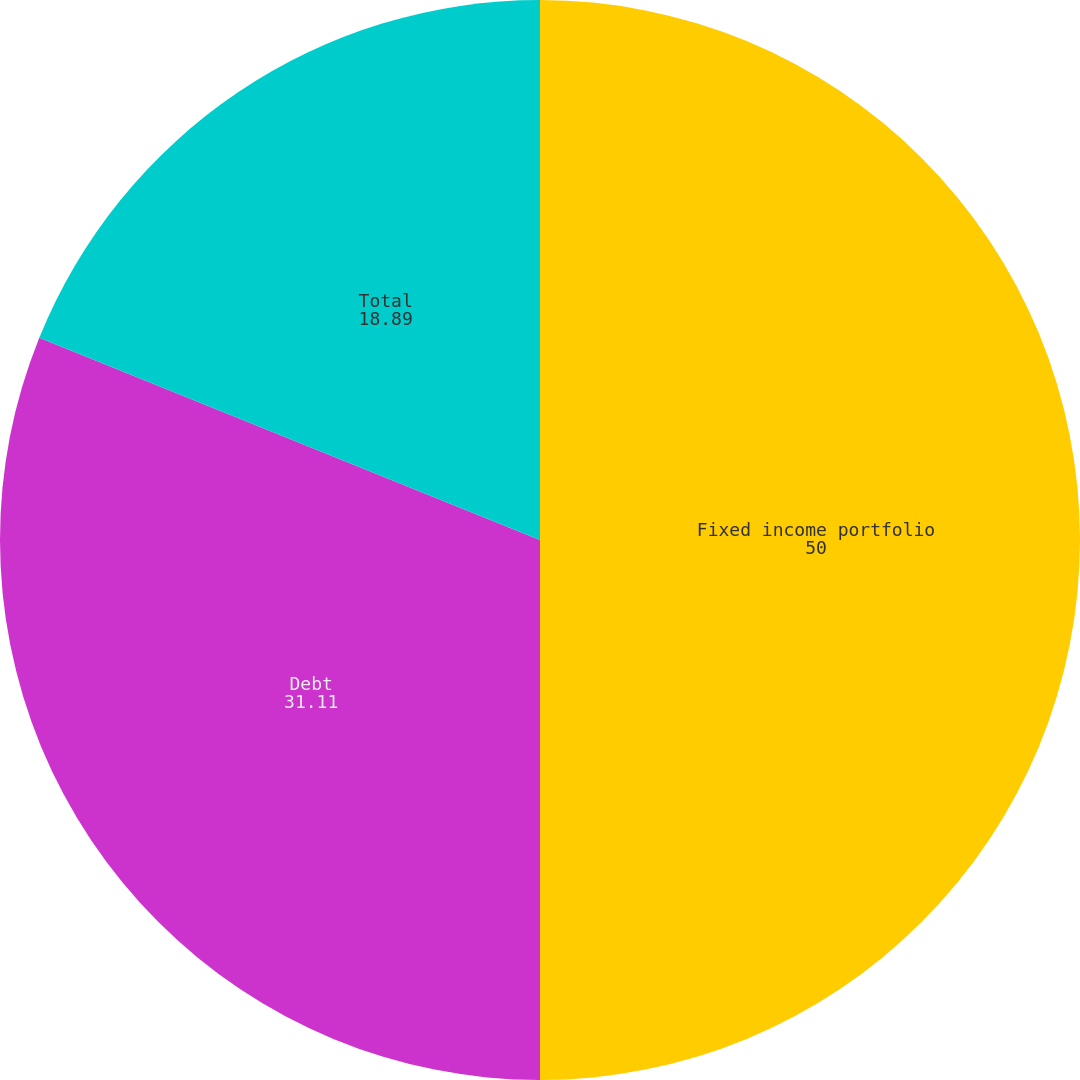Convert chart to OTSL. <chart><loc_0><loc_0><loc_500><loc_500><pie_chart><fcel>Fixed income portfolio<fcel>Debt<fcel>Total<nl><fcel>50.0%<fcel>31.11%<fcel>18.89%<nl></chart> 